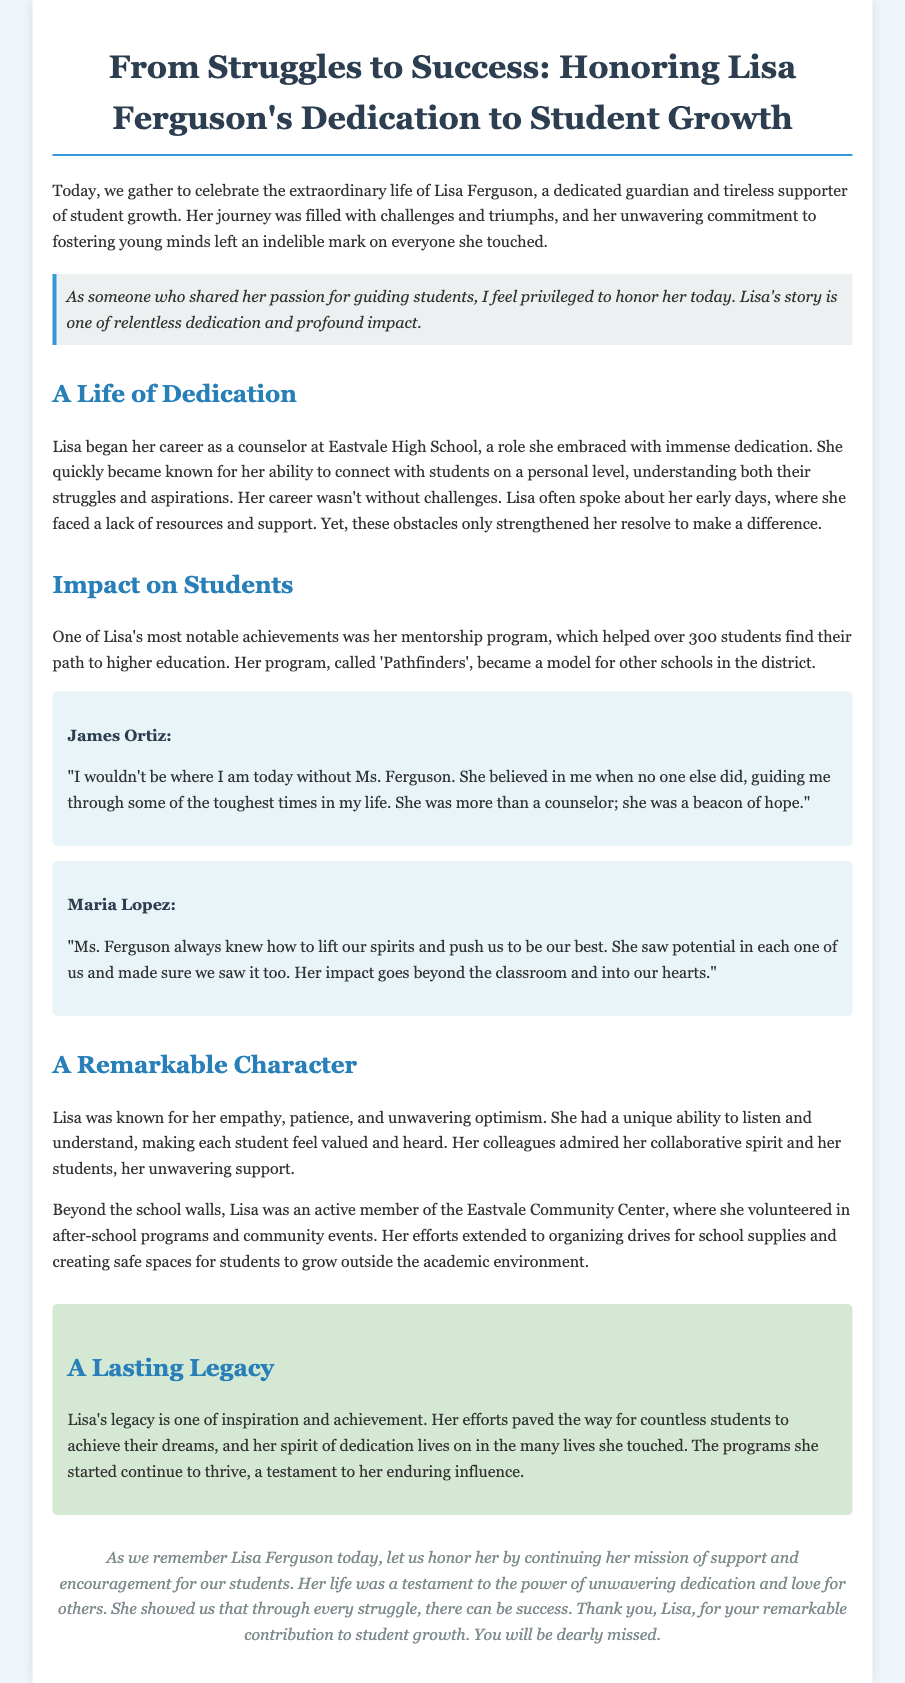What was Lisa Ferguson's role at Eastvale High School? Lisa Ferguson served as a counselor at Eastvale High School, where she embraced her role with immense dedication.
Answer: counselor How many students participated in the 'Pathfinders' mentorship program? The mentorship program named 'Pathfinders' helped over 300 students find their path to higher education.
Answer: over 300 What qualities was Lisa known for? Lisa was known for her empathy, patience, and unwavering optimism, which made students feel valued and heard.
Answer: empathy, patience, optimism Who provided a testimonial stating, "I wouldn't be where I am today without Ms. Ferguson"? James Ortiz provided a testimonial reflecting on the impact Lisa Ferguson had on his life.
Answer: James Ortiz What type of work did Lisa engage in at the Eastvale Community Center? Lisa was an active member of the Eastvale Community Center, volunteering in after-school programs and community events.
Answer: volunteering What is one way Lisa's legacy continues to thrive? The programs Lisa started continue to thrive, which is a testament to her enduring influence on students.
Answer: programs continue to thrive Why is Lisa Ferguson being honored in this document? Lisa Ferguson is being honored for her dedication to student growth and her profound impact on the students she supported.
Answer: dedication to student growth What did Lisa show about struggles and success? Lisa showed that through every struggle, there can be success, emphasizing the power of unwavering dedication.
Answer: every struggle, there can be success 